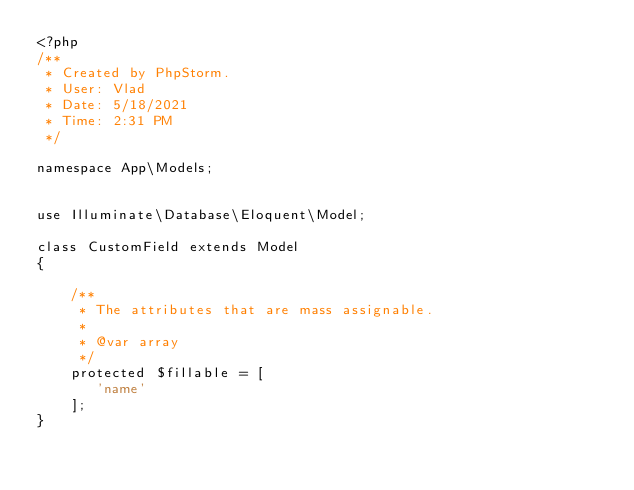<code> <loc_0><loc_0><loc_500><loc_500><_PHP_><?php
/**
 * Created by PhpStorm.
 * User: Vlad
 * Date: 5/18/2021
 * Time: 2:31 PM
 */

namespace App\Models;


use Illuminate\Database\Eloquent\Model;

class CustomField extends Model
{

    /**
     * The attributes that are mass assignable.
     *
     * @var array
     */
    protected $fillable = [
       'name'
    ];
}</code> 